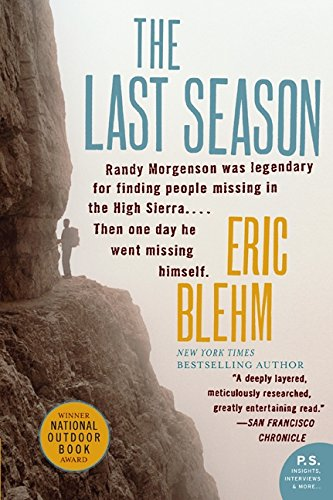What mountain range is discussed in this book? The book discusses the Sierra Nevada mountain range, a significant backdrop for the events portrayed in the narrative. 